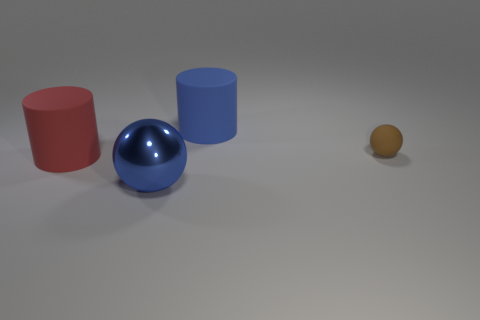Add 2 blue metal objects. How many objects exist? 6 Subtract 0 cyan cylinders. How many objects are left? 4 Subtract all blue objects. Subtract all big cyan shiny objects. How many objects are left? 2 Add 2 small brown matte spheres. How many small brown matte spheres are left? 3 Add 3 cyan spheres. How many cyan spheres exist? 3 